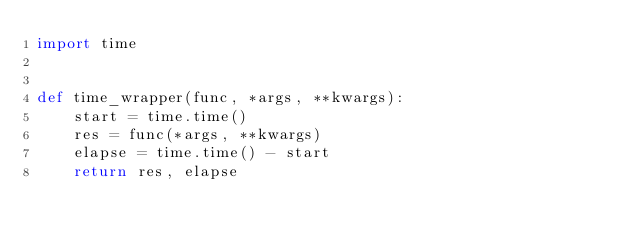Convert code to text. <code><loc_0><loc_0><loc_500><loc_500><_Python_>import time


def time_wrapper(func, *args, **kwargs):
    start = time.time()
    res = func(*args, **kwargs)
    elapse = time.time() - start
    return res, elapse
</code> 